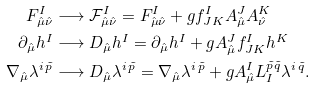Convert formula to latex. <formula><loc_0><loc_0><loc_500><loc_500>F ^ { I } _ { \hat { \mu } \hat { \nu } } & \longrightarrow \mathcal { F } ^ { I } _ { \hat { \mu } \hat { \nu } } = F ^ { I } _ { \hat { \mu } \hat { \nu } } + g f ^ { I } _ { J K } A ^ { J } _ { \hat { \mu } } A ^ { K } _ { \hat { \nu } } \\ \partial _ { \hat { \mu } } h ^ { I } & \longrightarrow D _ { \hat { \mu } } h ^ { I } = \partial _ { \hat { \mu } } h ^ { I } + g A ^ { J } _ { \hat { \mu } } f ^ { I } _ { J K } h ^ { K } \\ \nabla _ { \hat { \mu } } \lambda ^ { i \, \tilde { p } } & \longrightarrow D _ { \hat { \mu } } \lambda ^ { i \, \tilde { p } } = \nabla _ { \hat { \mu } } \lambda ^ { i \, \tilde { p } } + g A ^ { I } _ { \hat { \mu } } L ^ { \tilde { p } \tilde { q } } _ { I } \lambda ^ { i \, \tilde { q } } .</formula> 